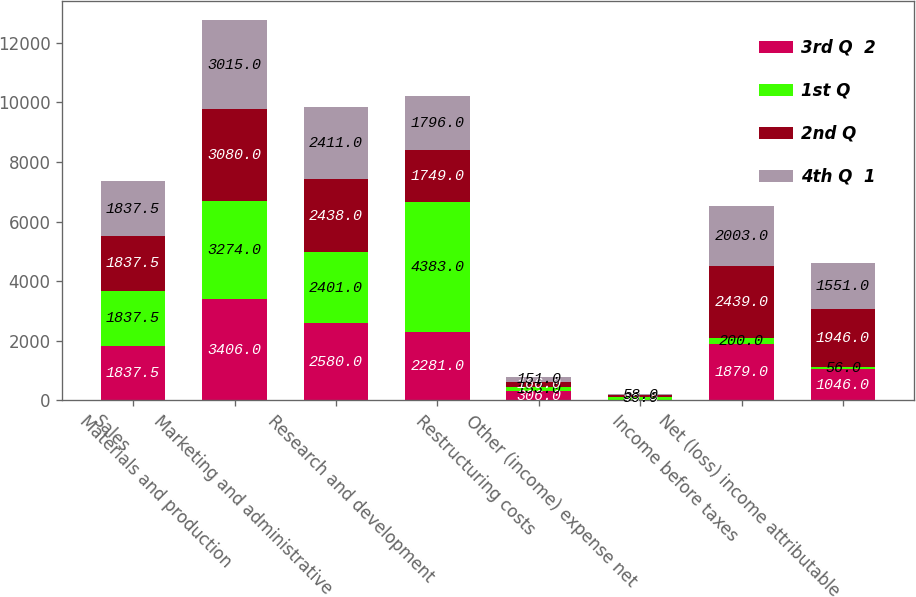Convert chart. <chart><loc_0><loc_0><loc_500><loc_500><stacked_bar_chart><ecel><fcel>Sales<fcel>Materials and production<fcel>Marketing and administrative<fcel>Research and development<fcel>Restructuring costs<fcel>Other (income) expense net<fcel>Income before taxes<fcel>Net (loss) income attributable<nl><fcel>3rd Q  2<fcel>1837.5<fcel>3406<fcel>2580<fcel>2281<fcel>306<fcel>19<fcel>1879<fcel>1046<nl><fcel>1st Q<fcel>1837.5<fcel>3274<fcel>2401<fcel>4383<fcel>153<fcel>86<fcel>200<fcel>56<nl><fcel>2nd Q<fcel>1837.5<fcel>3080<fcel>2438<fcel>1749<fcel>166<fcel>58<fcel>2439<fcel>1946<nl><fcel>4th Q  1<fcel>1837.5<fcel>3015<fcel>2411<fcel>1796<fcel>151<fcel>58<fcel>2003<fcel>1551<nl></chart> 